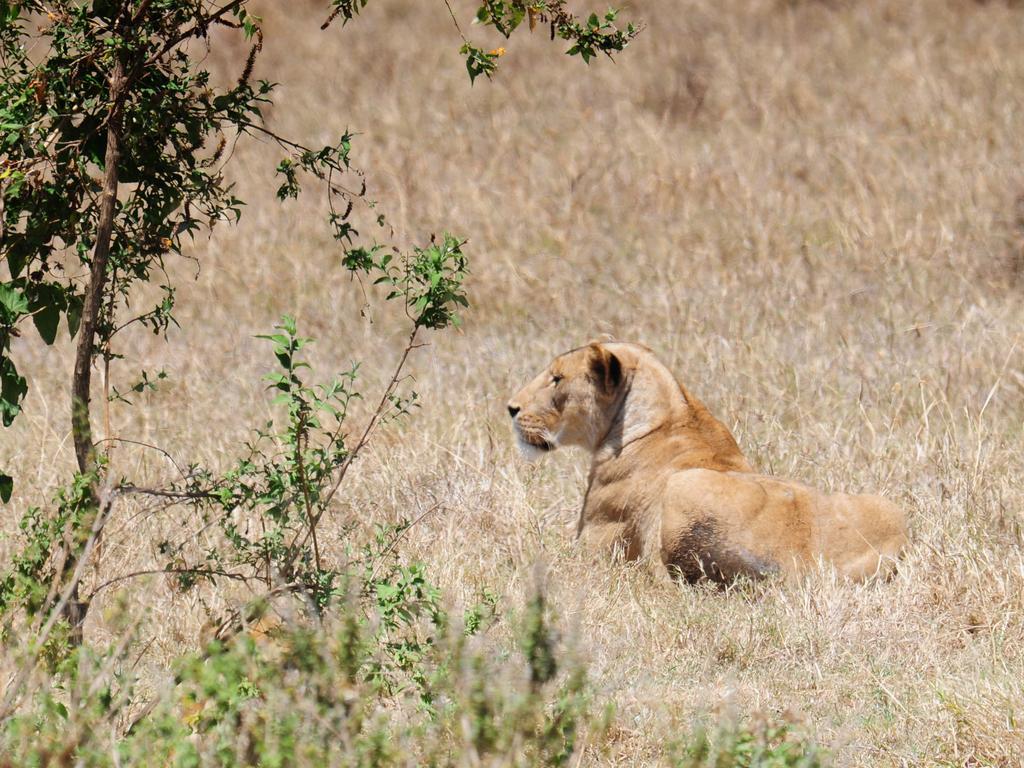Please provide a concise description of this image. In the middle of the picture, we see a lion. On the left side, we see trees. In the background, we see dry grass. This picture might be clicked in the forest or in a zoo. 